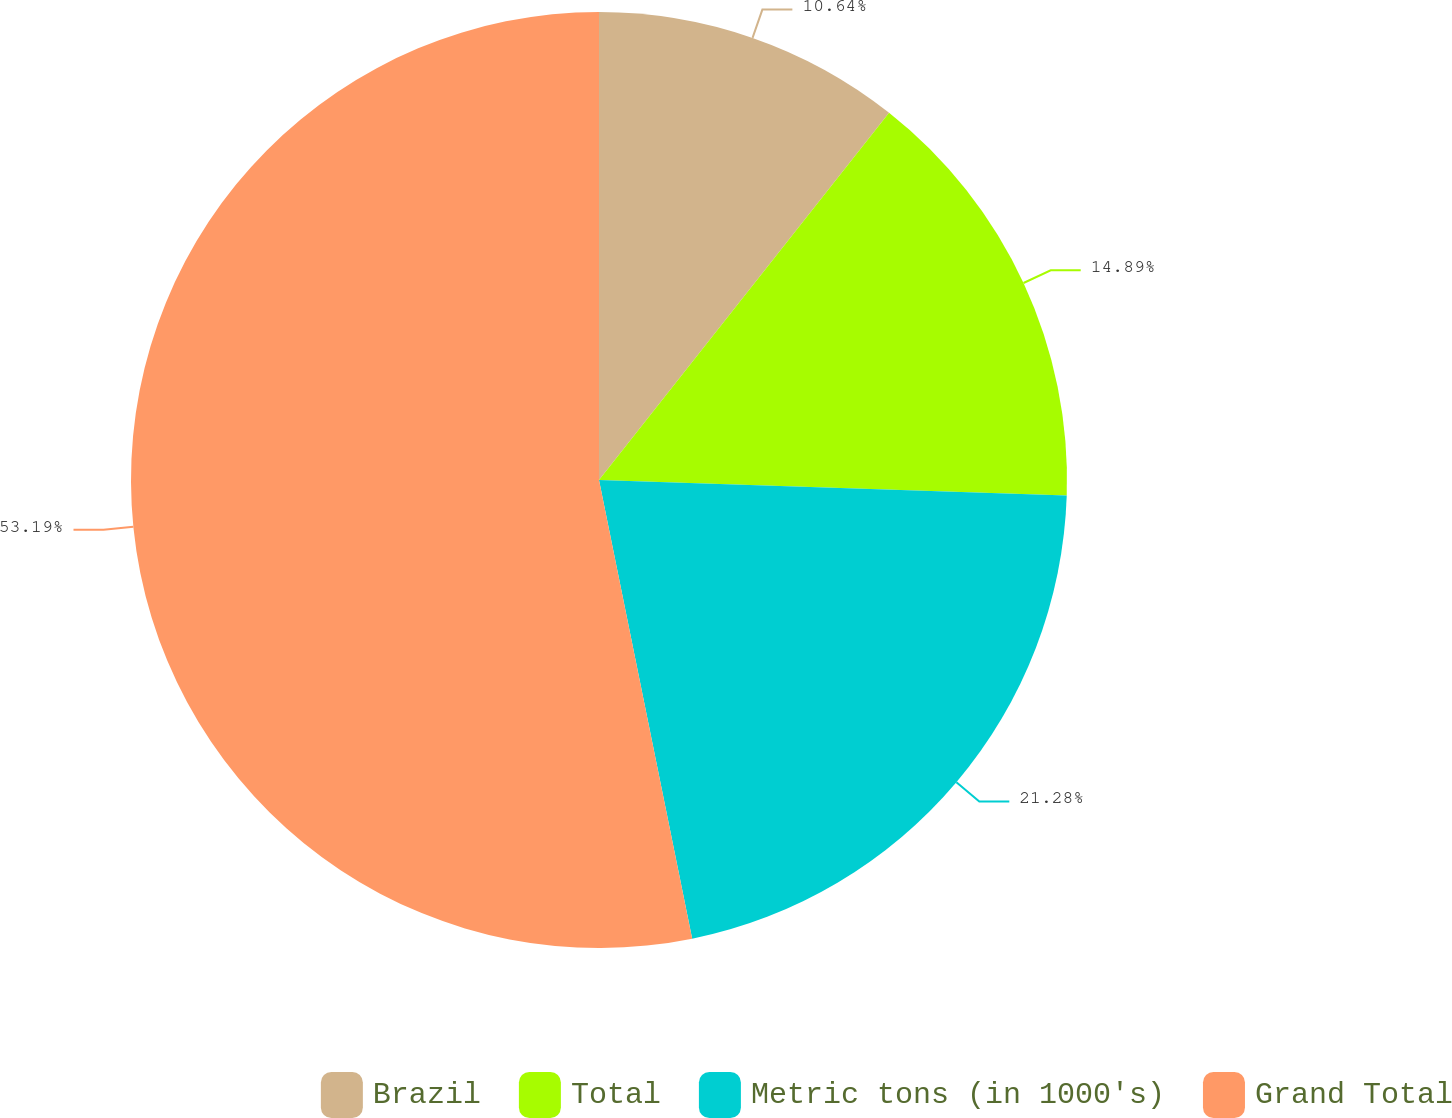Convert chart. <chart><loc_0><loc_0><loc_500><loc_500><pie_chart><fcel>Brazil<fcel>Total<fcel>Metric tons (in 1000's)<fcel>Grand Total<nl><fcel>10.64%<fcel>14.89%<fcel>21.28%<fcel>53.19%<nl></chart> 